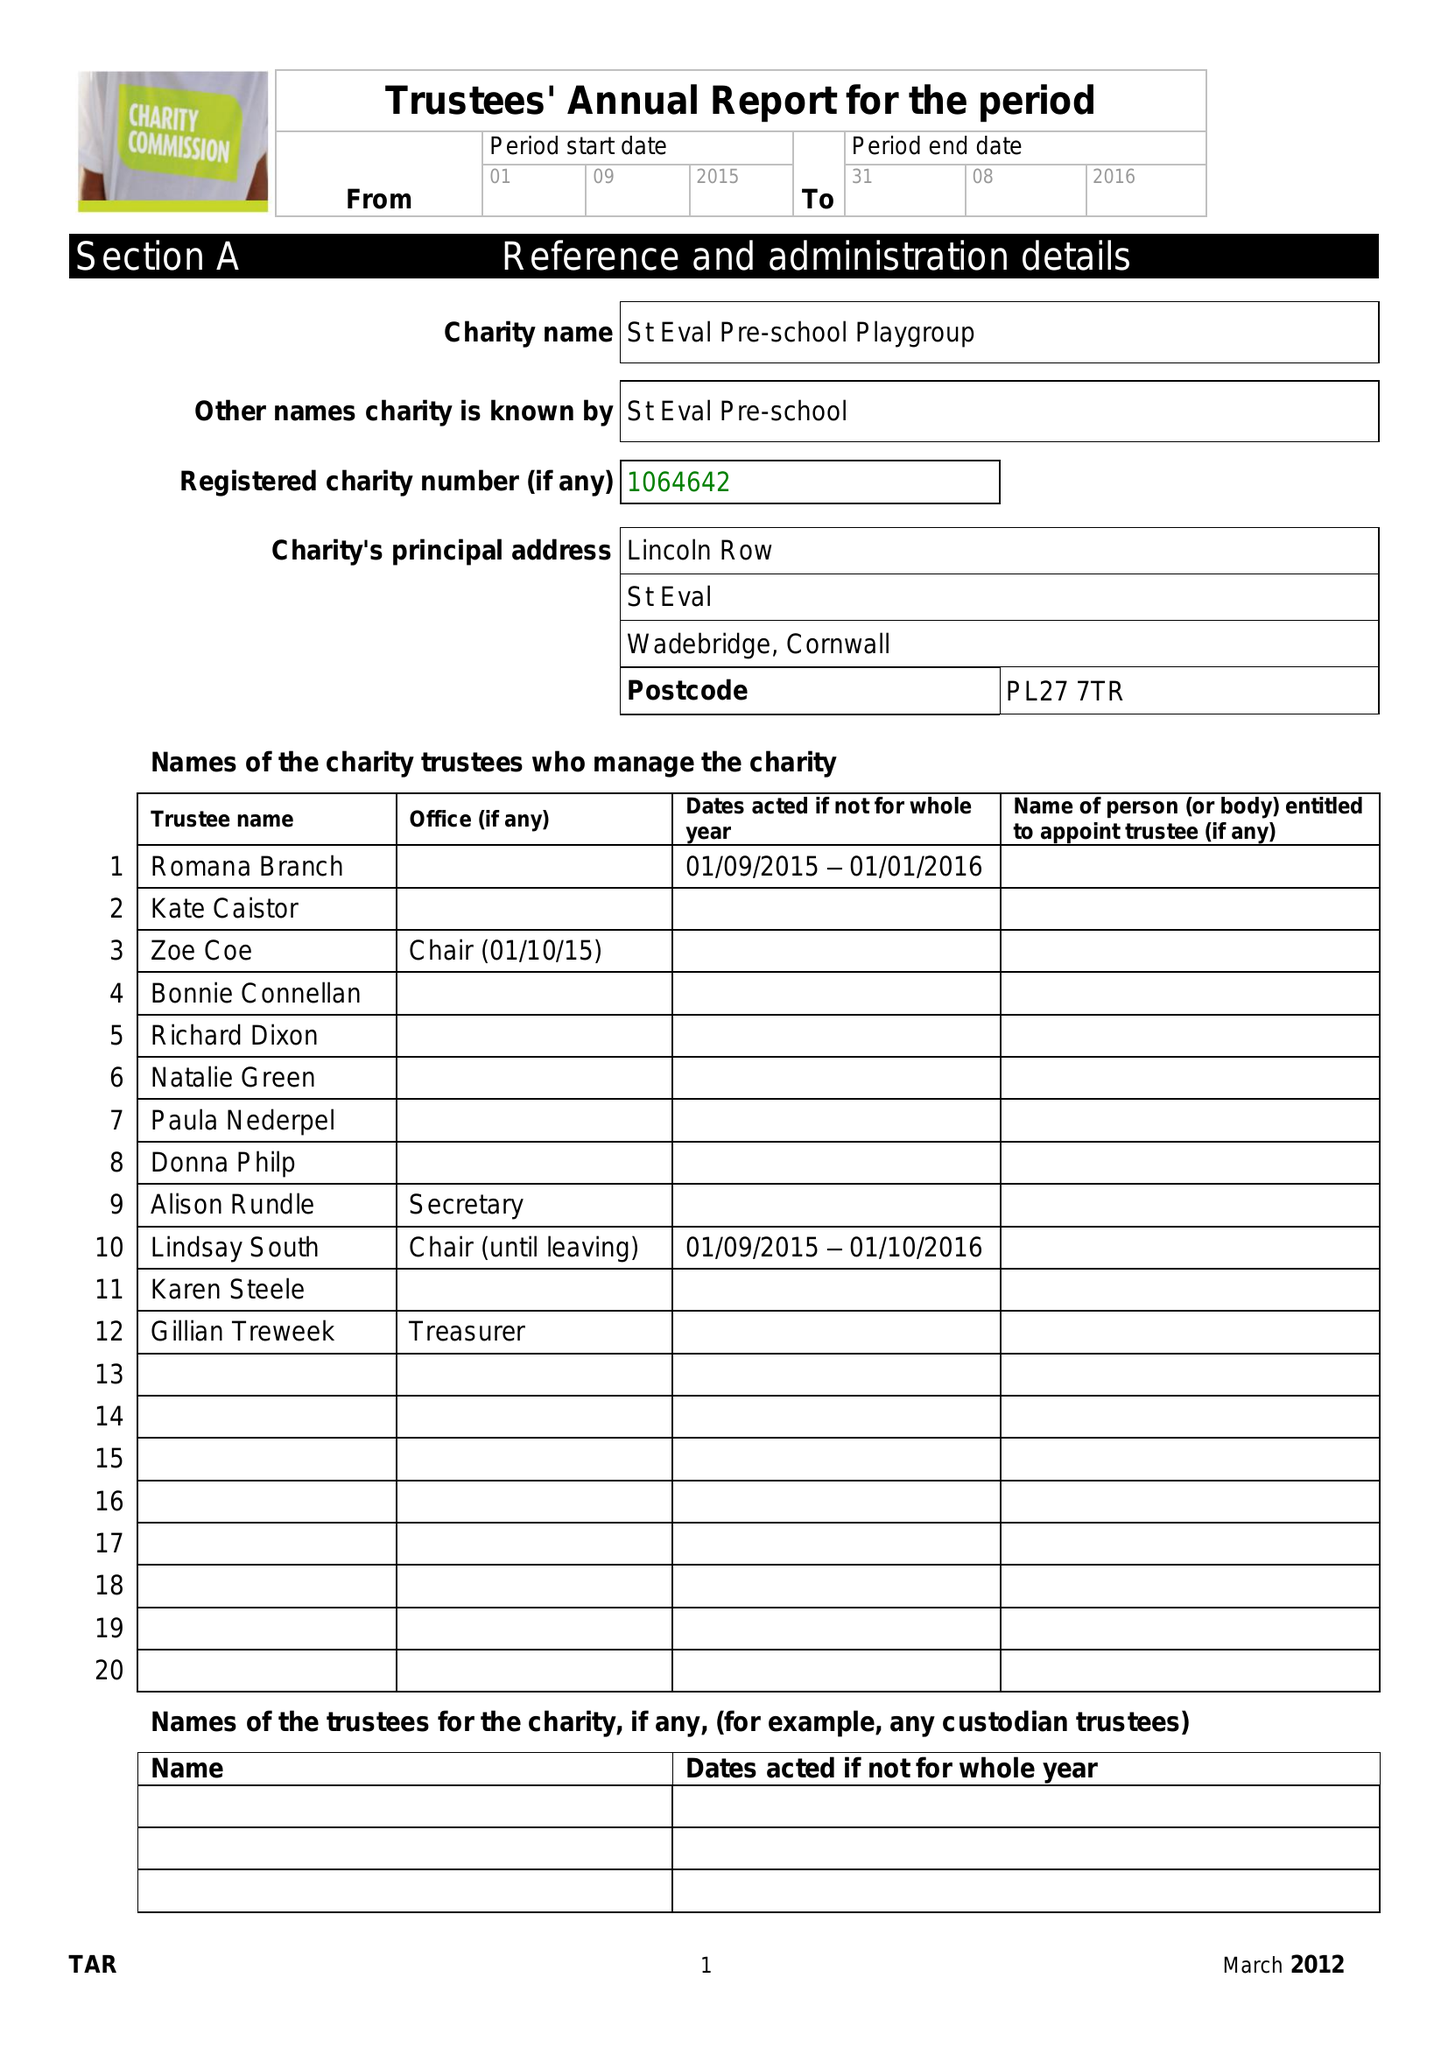What is the value for the address__postcode?
Answer the question using a single word or phrase. PL27 7TR 